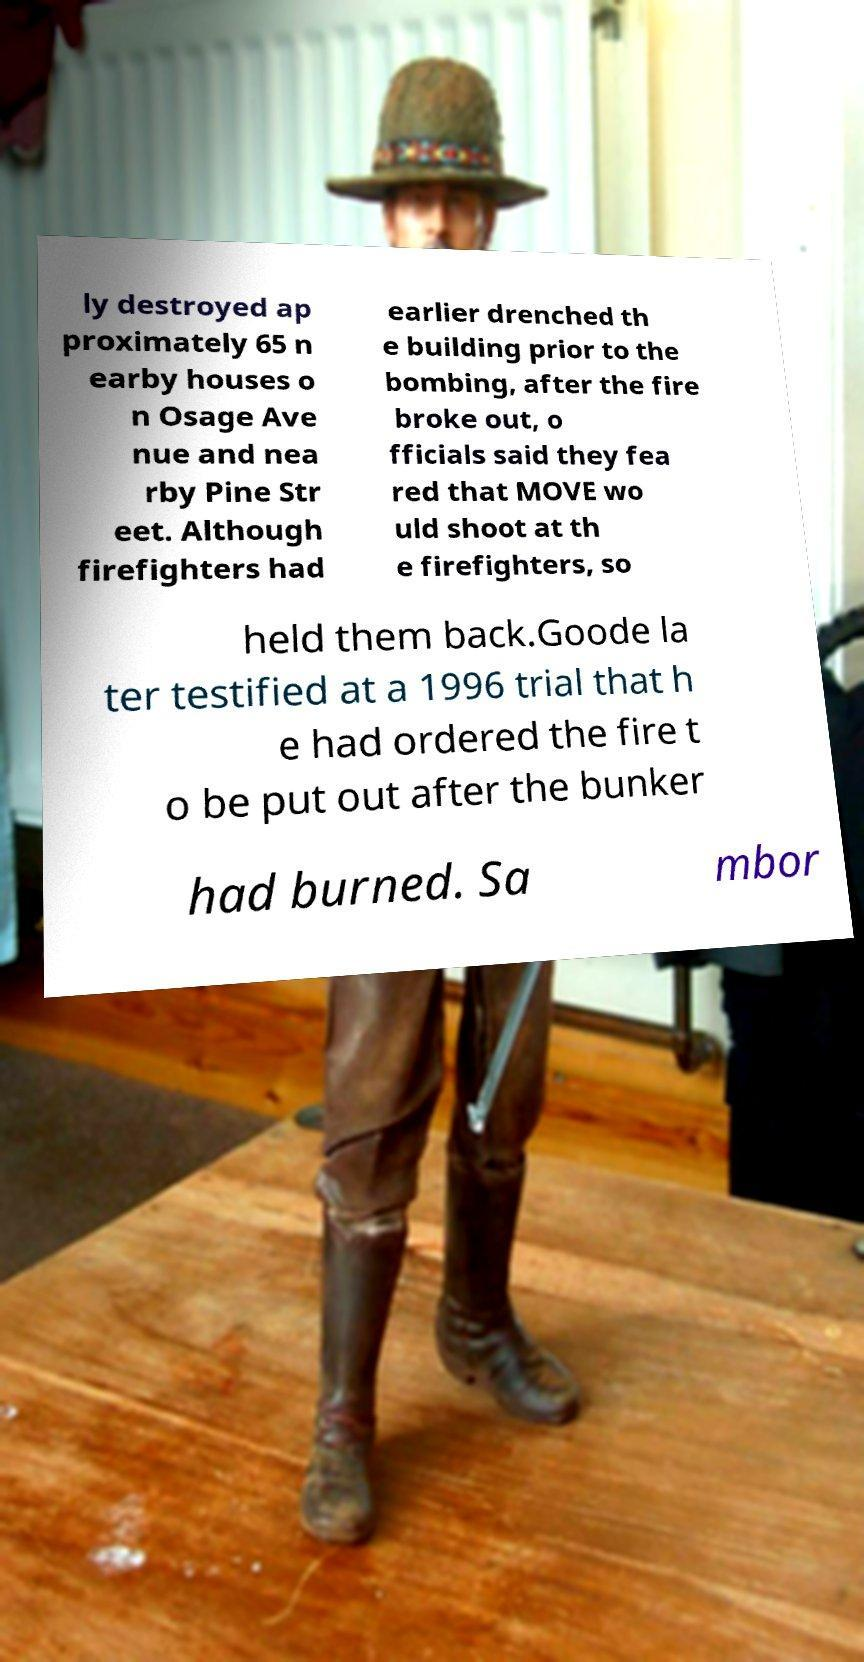I need the written content from this picture converted into text. Can you do that? ly destroyed ap proximately 65 n earby houses o n Osage Ave nue and nea rby Pine Str eet. Although firefighters had earlier drenched th e building prior to the bombing, after the fire broke out, o fficials said they fea red that MOVE wo uld shoot at th e firefighters, so held them back.Goode la ter testified at a 1996 trial that h e had ordered the fire t o be put out after the bunker had burned. Sa mbor 